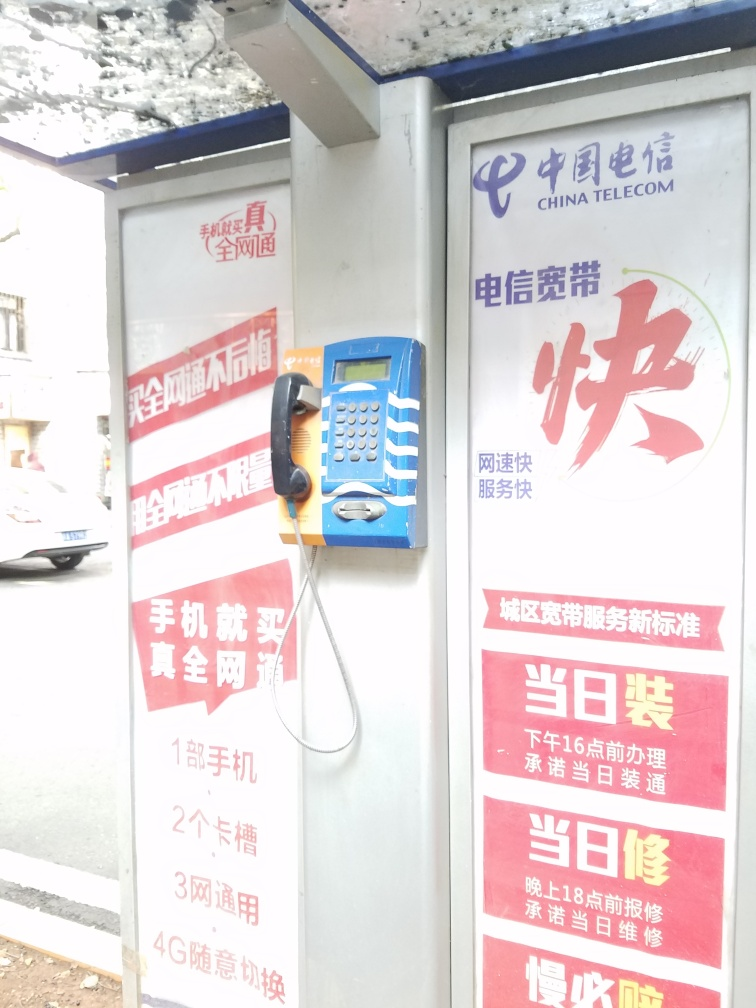What might this image say about the location it was taken? The presence of Chinese characters on the posters and the China Telecom logo suggests that the photo was taken in a Chinese-speaking region, likely in China itself. The posters indicate the promotion of services such as broadband, which reflects a mix of modern connectivity options in the context of more traditional phone booth services. 